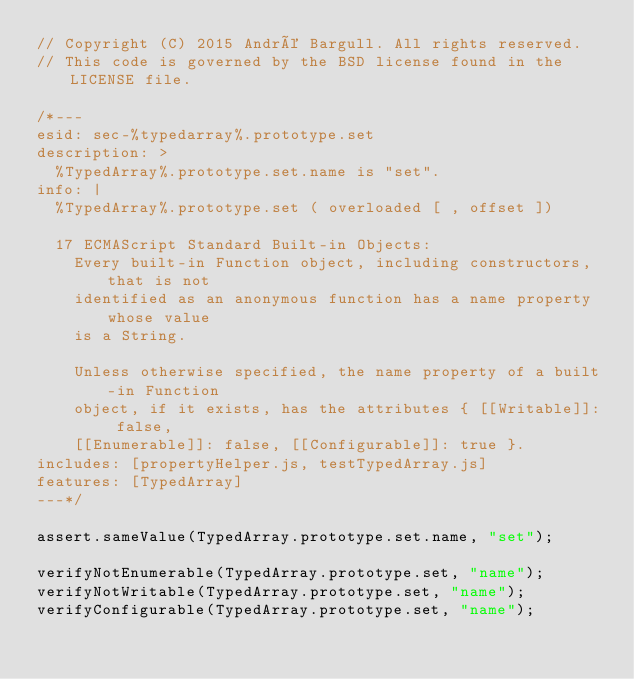<code> <loc_0><loc_0><loc_500><loc_500><_JavaScript_>// Copyright (C) 2015 André Bargull. All rights reserved.
// This code is governed by the BSD license found in the LICENSE file.

/*---
esid: sec-%typedarray%.prototype.set
description: >
  %TypedArray%.prototype.set.name is "set".
info: |
  %TypedArray%.prototype.set ( overloaded [ , offset ])

  17 ECMAScript Standard Built-in Objects:
    Every built-in Function object, including constructors, that is not
    identified as an anonymous function has a name property whose value
    is a String.

    Unless otherwise specified, the name property of a built-in Function
    object, if it exists, has the attributes { [[Writable]]: false,
    [[Enumerable]]: false, [[Configurable]]: true }.
includes: [propertyHelper.js, testTypedArray.js]
features: [TypedArray]
---*/

assert.sameValue(TypedArray.prototype.set.name, "set");

verifyNotEnumerable(TypedArray.prototype.set, "name");
verifyNotWritable(TypedArray.prototype.set, "name");
verifyConfigurable(TypedArray.prototype.set, "name");
</code> 